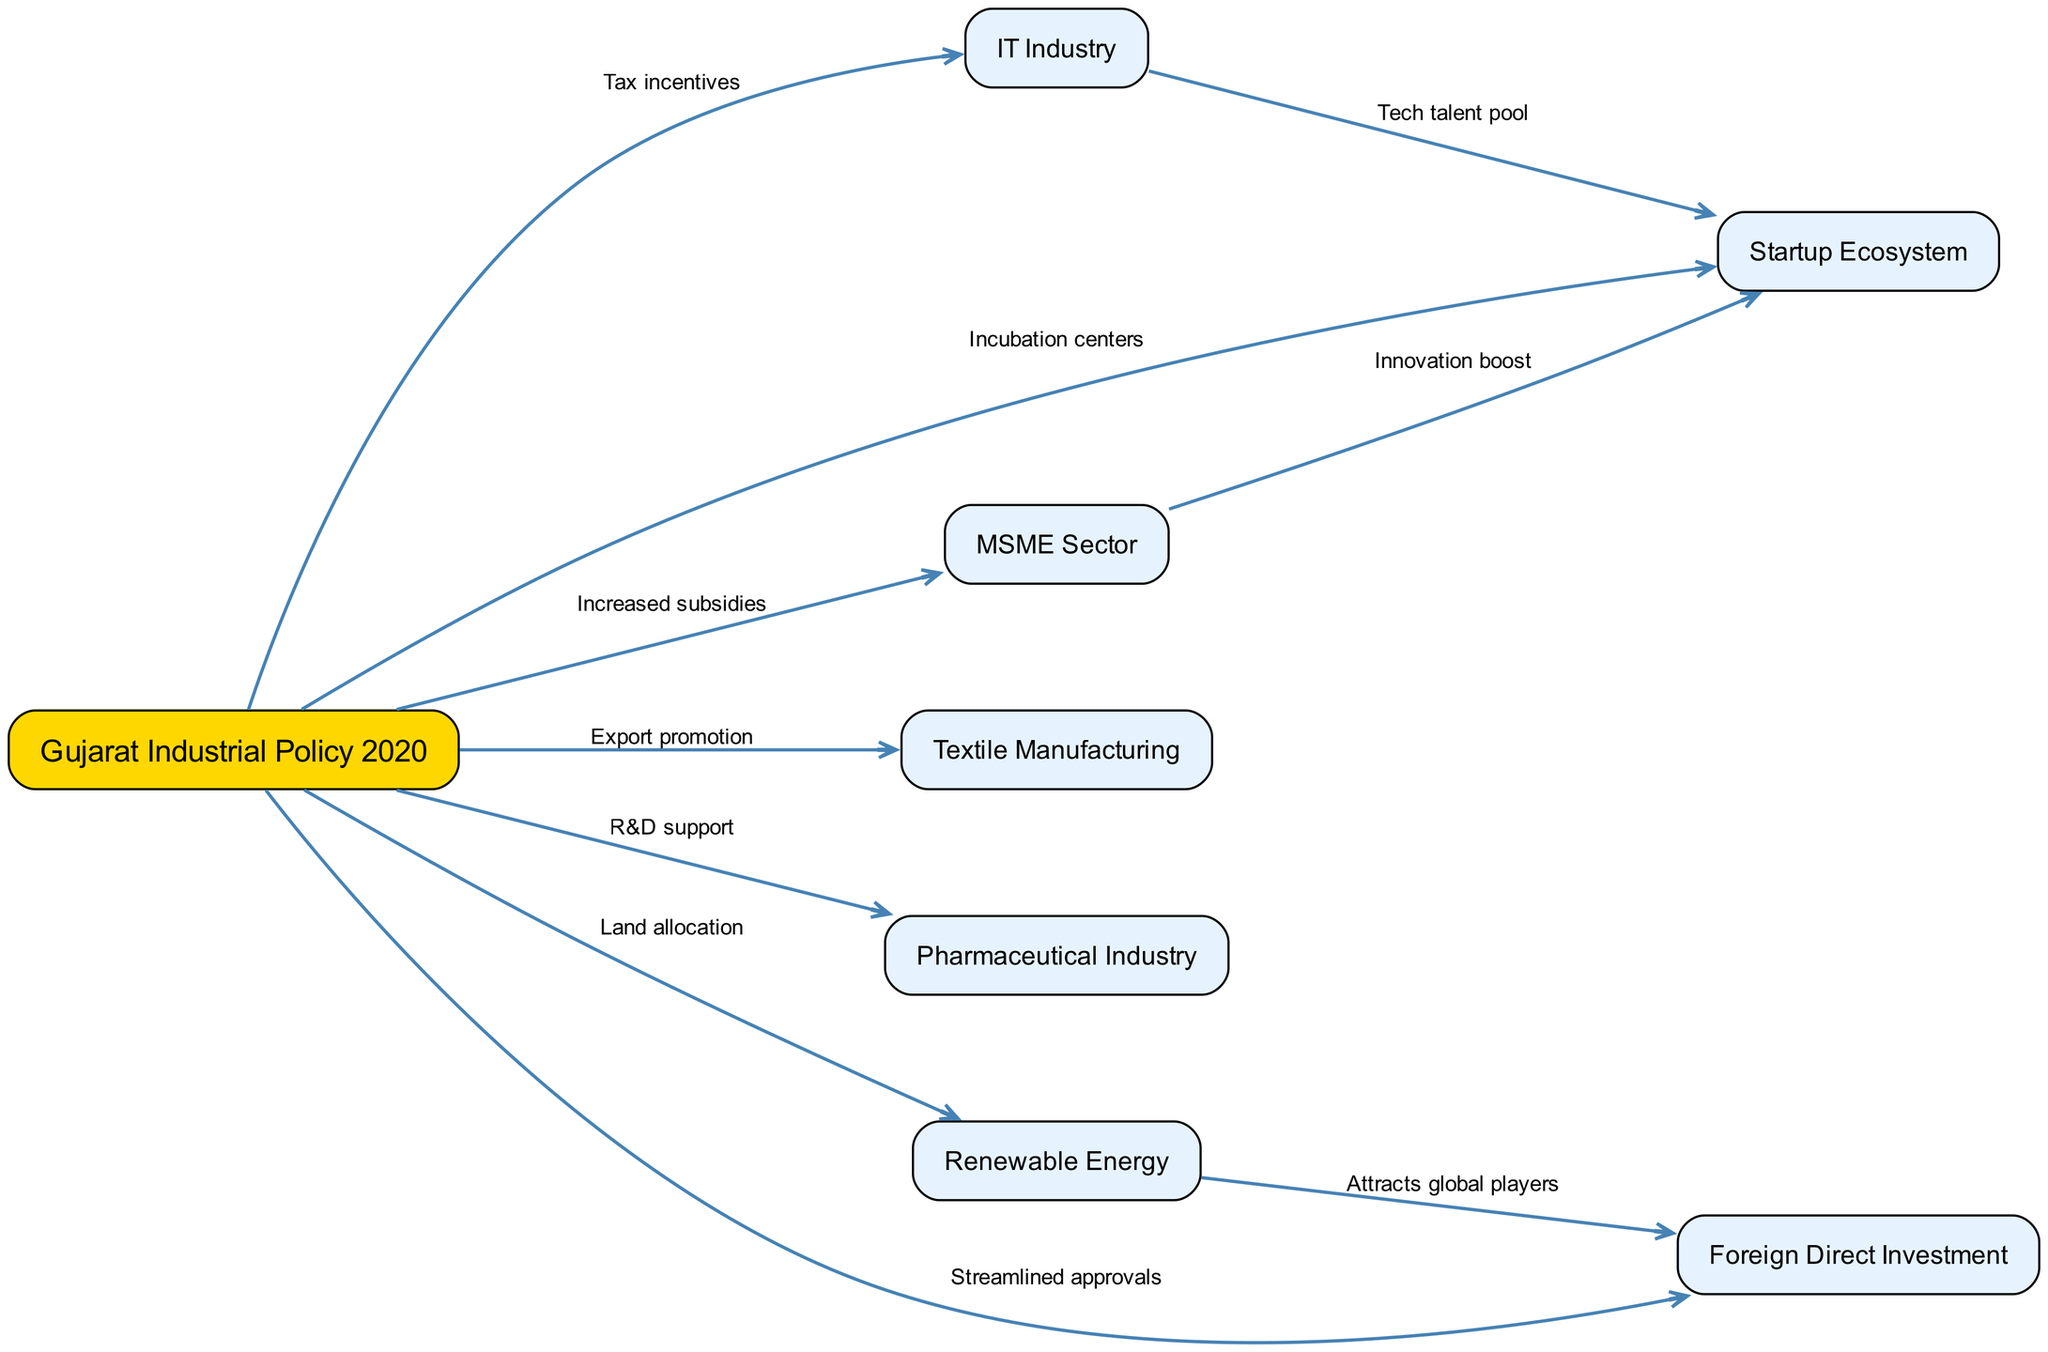What is the total number of nodes in the diagram? The diagram includes a list of nodes related to Gujarat's industrial policies and sectors. Counting each unique entry in the "nodes" list gives a total of 8 nodes.
Answer: 8 What sector receives R&D support from the Gujarat Industrial Policy 2020? Looking at the edges extending from "Gujarat Industrial Policy 2020," the edge labeled "R&D support" points to the "Pharmaceutical Industry."
Answer: Pharmaceutical Industry Which policy directly influences the Startup Ecosystem? Observing the directed edges, "Gujarat Industrial Policy 2020" has an edge labeled "Incubation centers" directed toward "Startup Ecosystem," thus indicating it influences this sector directly.
Answer: Gujarat Industrial Policy 2020 What type of incentives are provided to the IT Industry? The edge leading from "Gujarat Industrial Policy 2020" to "IT Industry" is labeled "Tax incentives," indicating that this is the type of support provided to the IT sector.
Answer: Tax incentives Which industry attracts foreign players due to a specific directed edge? The edge from "Renewable Energy" to "Foreign Direct Investment," noting the label "Attracts global players," indicates that the Renewable Energy sector is the one that attracts foreign players.
Answer: Renewable Energy How many unique relationships are illustrated in the diagram? Each directed edge represents a unique relationship between the nodes. By counting the edges listed in the "edges" structure, we find there are a total of 10 edges illustrating these relationships.
Answer: 10 Which sector benefits from an innovation boost due to the MSME sector? The edge labeled "Innovation boost" directed from "MSME Sector" to "Startup Ecosystem" shows that the Startup Ecosystem benefits from this boost.
Answer: Startup Ecosystem How does the Gujarat Industrial Policy 2020 influence Foreign Direct Investment? There is a directed edge from "Gujarat Industrial Policy 2020" to "Foreign Direct Investment," labeled "Streamlined approvals," showing that this policy influences foreign investments through simplified processes.
Answer: Streamlined approvals What are the nodes directly influenced by Gujarat Industrial Policy 2020? To answer this, we look at all edges stemming from "Gujarat Industrial Policy 2020." The influenced nodes are "MSME Sector," "IT Industry," "Renewable Energy," "Textile Manufacturing," "Pharmaceutical Industry," "Startup Ecosystem," and "Foreign Direct Investment," totaling 7.
Answer: 7 nodes: MSME Sector, IT Industry, Renewable Energy, Textile Manufacturing, Pharmaceutical Industry, Startup Ecosystem, Foreign Direct Investment 